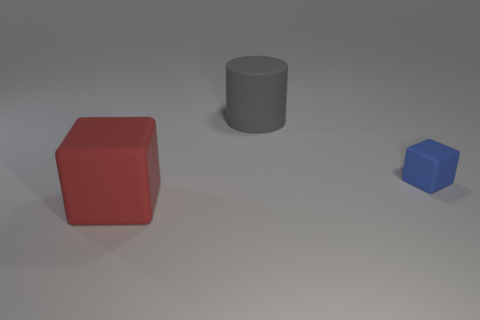Subtract all small rubber things. Subtract all red blocks. How many objects are left? 1 Add 2 tiny matte cubes. How many tiny matte cubes are left? 3 Add 3 small green rubber balls. How many small green rubber balls exist? 3 Add 2 big red objects. How many objects exist? 5 Subtract all red blocks. How many blocks are left? 1 Subtract 0 yellow balls. How many objects are left? 3 Subtract all cylinders. How many objects are left? 2 Subtract 1 blocks. How many blocks are left? 1 Subtract all yellow cubes. Subtract all green cylinders. How many cubes are left? 2 Subtract all cyan balls. How many cyan blocks are left? 0 